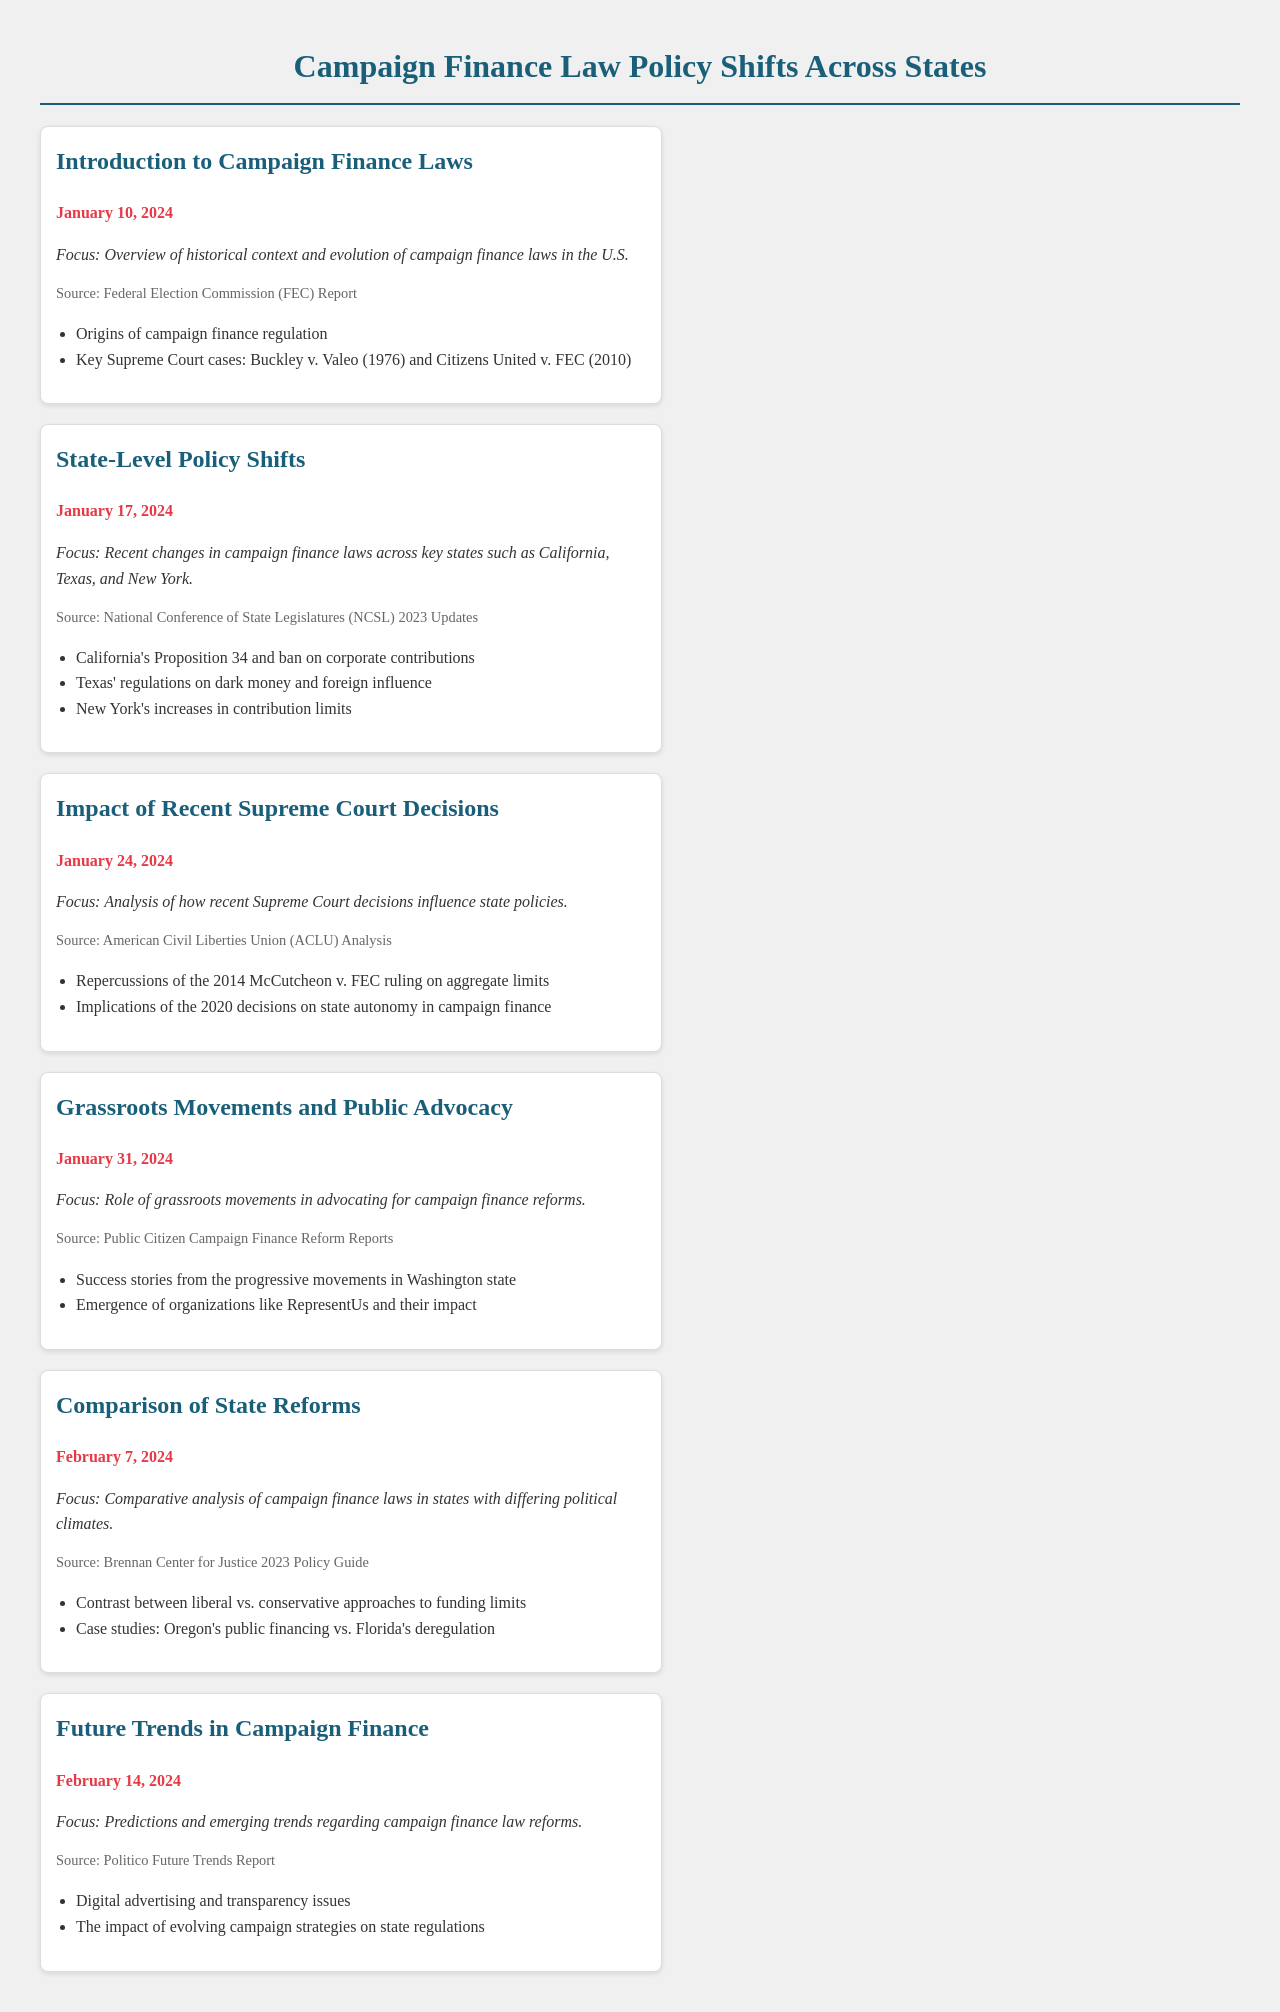What is the date of the introduction to campaign finance laws? The event lists "January 10, 2024" as the date for the introduction to campaign finance laws.
Answer: January 10, 2024 Which state had a ban on corporate contributions? The document mentions California's Proposition 34, which includes a ban on corporate contributions.
Answer: California What is the primary focus of the event on January 24, 2024? The event is focused on analyzing the impact of recent Supreme Court decisions on state policies.
Answer: Analysis of how recent Supreme Court decisions influence state policies What organization is cited as a source regarding grassroots movements? The document references Public Citizen Campaign Finance Reform Reports as the source for grassroots movements and public advocacy.
Answer: Public Citizen How many events are scheduled in February 2024? There are three scheduled events listed for February 2024.
Answer: Three What contrasting approaches are highlighted in the comparison of state reforms? The document highlights the contrast between liberal and conservative approaches to funding limits.
Answer: Liberal vs. conservative approaches Which Supreme Court ruling's repercussions are discussed in the context of recent decisions influencing campaign finance? The document discusses the repercussions of the 2014 McCutcheon v. FEC ruling.
Answer: McCutcheon v. FEC What is a key theme of the event scheduled for February 14, 2024? The event focuses on predictions and emerging trends regarding campaign finance law reforms.
Answer: Predictions and emerging trends regarding campaign finance law reforms 